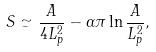Convert formula to latex. <formula><loc_0><loc_0><loc_500><loc_500>S \simeq \frac { A } { 4 L _ { p } ^ { 2 } } - \alpha \pi \ln \frac { A } { L _ { p } ^ { 2 } } ,</formula> 